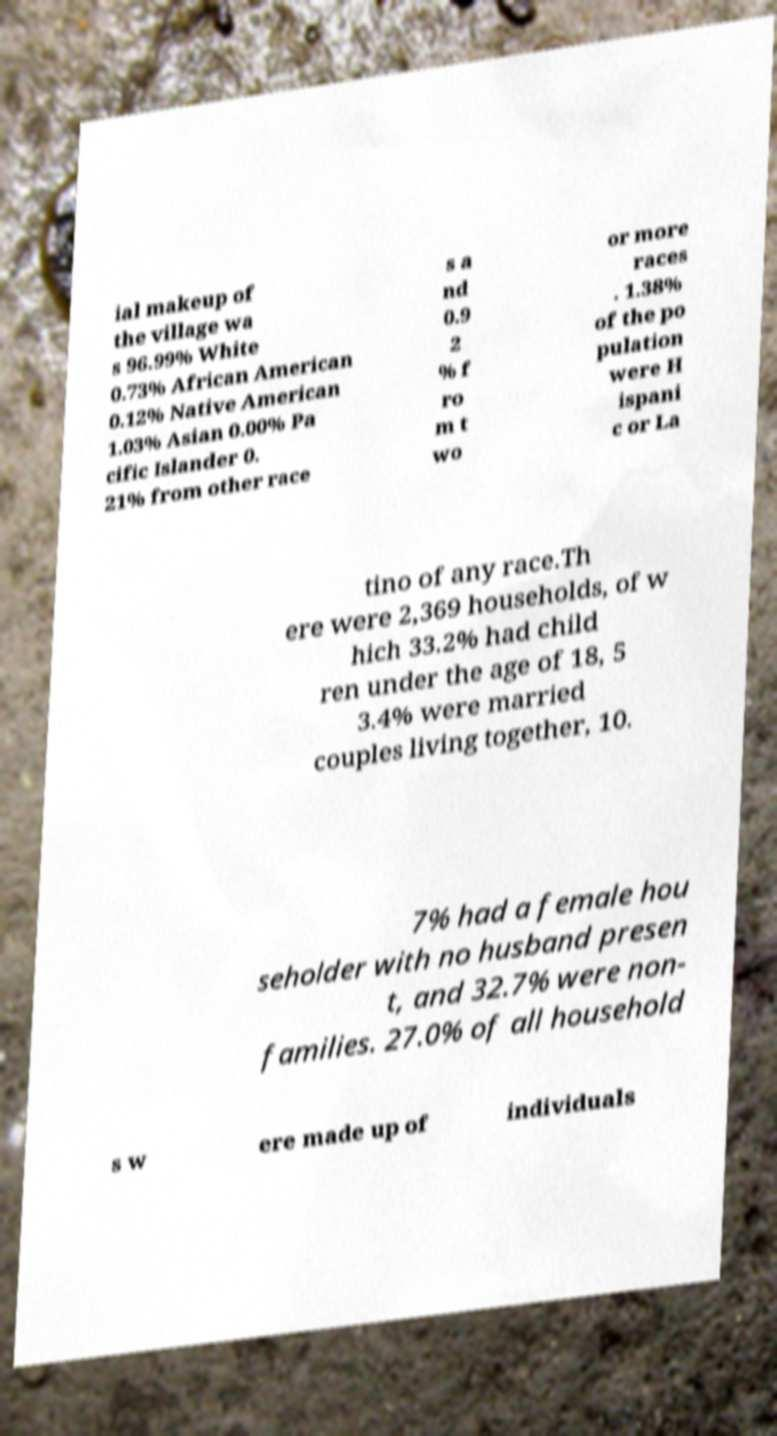There's text embedded in this image that I need extracted. Can you transcribe it verbatim? ial makeup of the village wa s 96.99% White 0.73% African American 0.12% Native American 1.03% Asian 0.00% Pa cific Islander 0. 21% from other race s a nd 0.9 2 % f ro m t wo or more races . 1.38% of the po pulation were H ispani c or La tino of any race.Th ere were 2,369 households, of w hich 33.2% had child ren under the age of 18, 5 3.4% were married couples living together, 10. 7% had a female hou seholder with no husband presen t, and 32.7% were non- families. 27.0% of all household s w ere made up of individuals 